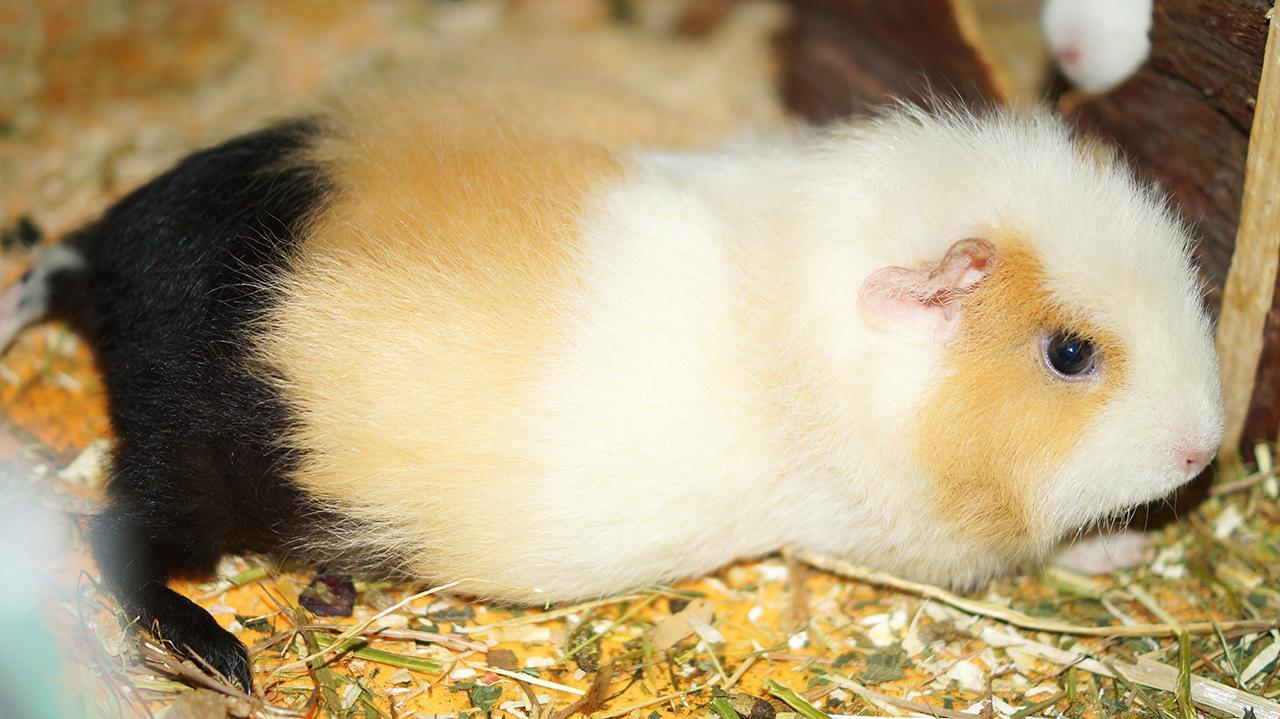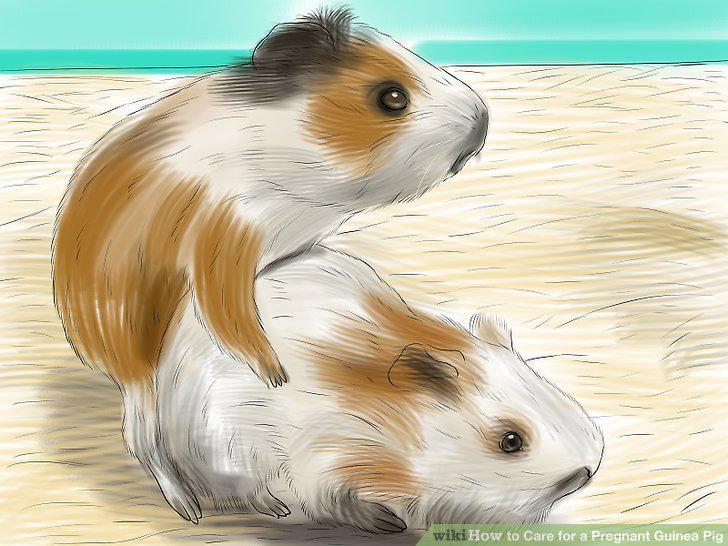The first image is the image on the left, the second image is the image on the right. For the images shown, is this caption "There are fewer than four guinea pigs in both images." true? Answer yes or no. Yes. 